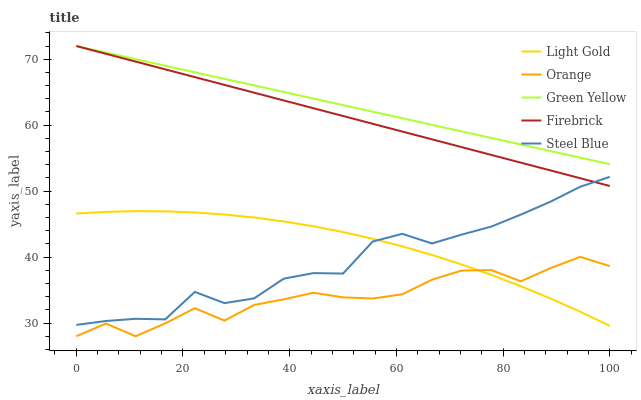Does Orange have the minimum area under the curve?
Answer yes or no. Yes. Does Green Yellow have the maximum area under the curve?
Answer yes or no. Yes. Does Firebrick have the minimum area under the curve?
Answer yes or no. No. Does Firebrick have the maximum area under the curve?
Answer yes or no. No. Is Green Yellow the smoothest?
Answer yes or no. Yes. Is Steel Blue the roughest?
Answer yes or no. Yes. Is Firebrick the smoothest?
Answer yes or no. No. Is Firebrick the roughest?
Answer yes or no. No. Does Orange have the lowest value?
Answer yes or no. Yes. Does Firebrick have the lowest value?
Answer yes or no. No. Does Green Yellow have the highest value?
Answer yes or no. Yes. Does Light Gold have the highest value?
Answer yes or no. No. Is Light Gold less than Green Yellow?
Answer yes or no. Yes. Is Steel Blue greater than Orange?
Answer yes or no. Yes. Does Firebrick intersect Green Yellow?
Answer yes or no. Yes. Is Firebrick less than Green Yellow?
Answer yes or no. No. Is Firebrick greater than Green Yellow?
Answer yes or no. No. Does Light Gold intersect Green Yellow?
Answer yes or no. No. 